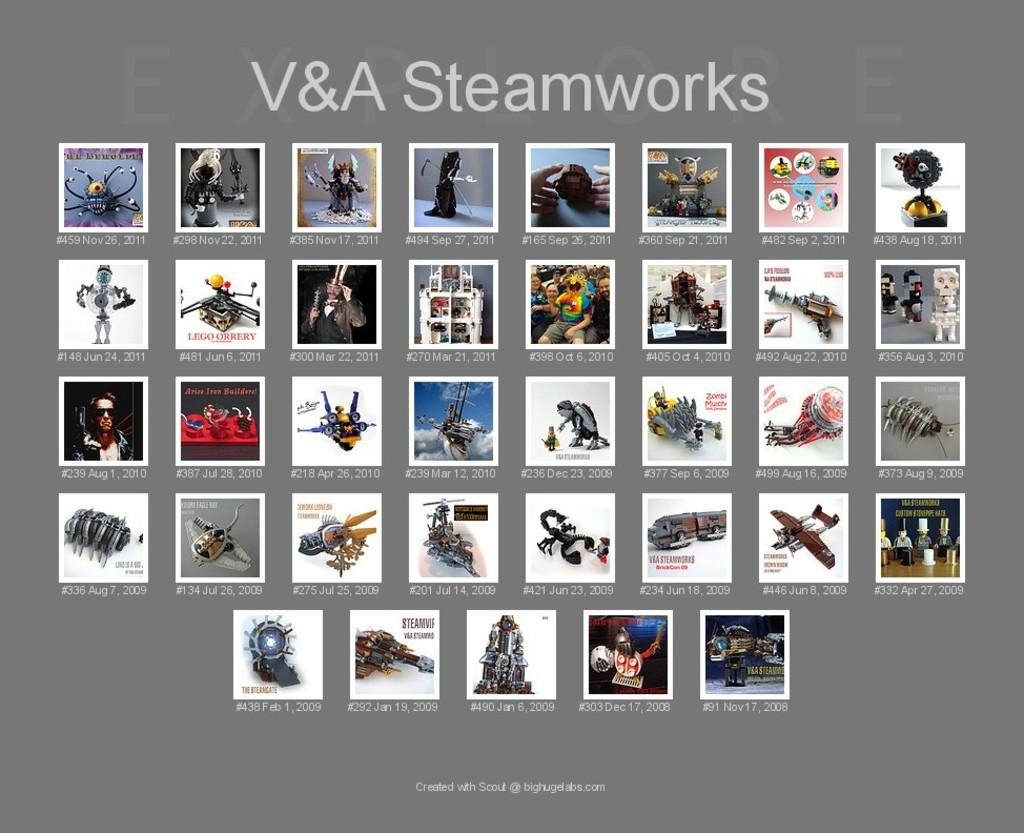<image>
Share a concise interpretation of the image provided. A V&A steamworks art collection with 29 pieces of art 